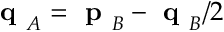<formula> <loc_0><loc_0><loc_500><loc_500>q _ { A } = p _ { B } - q _ { B } / 2</formula> 